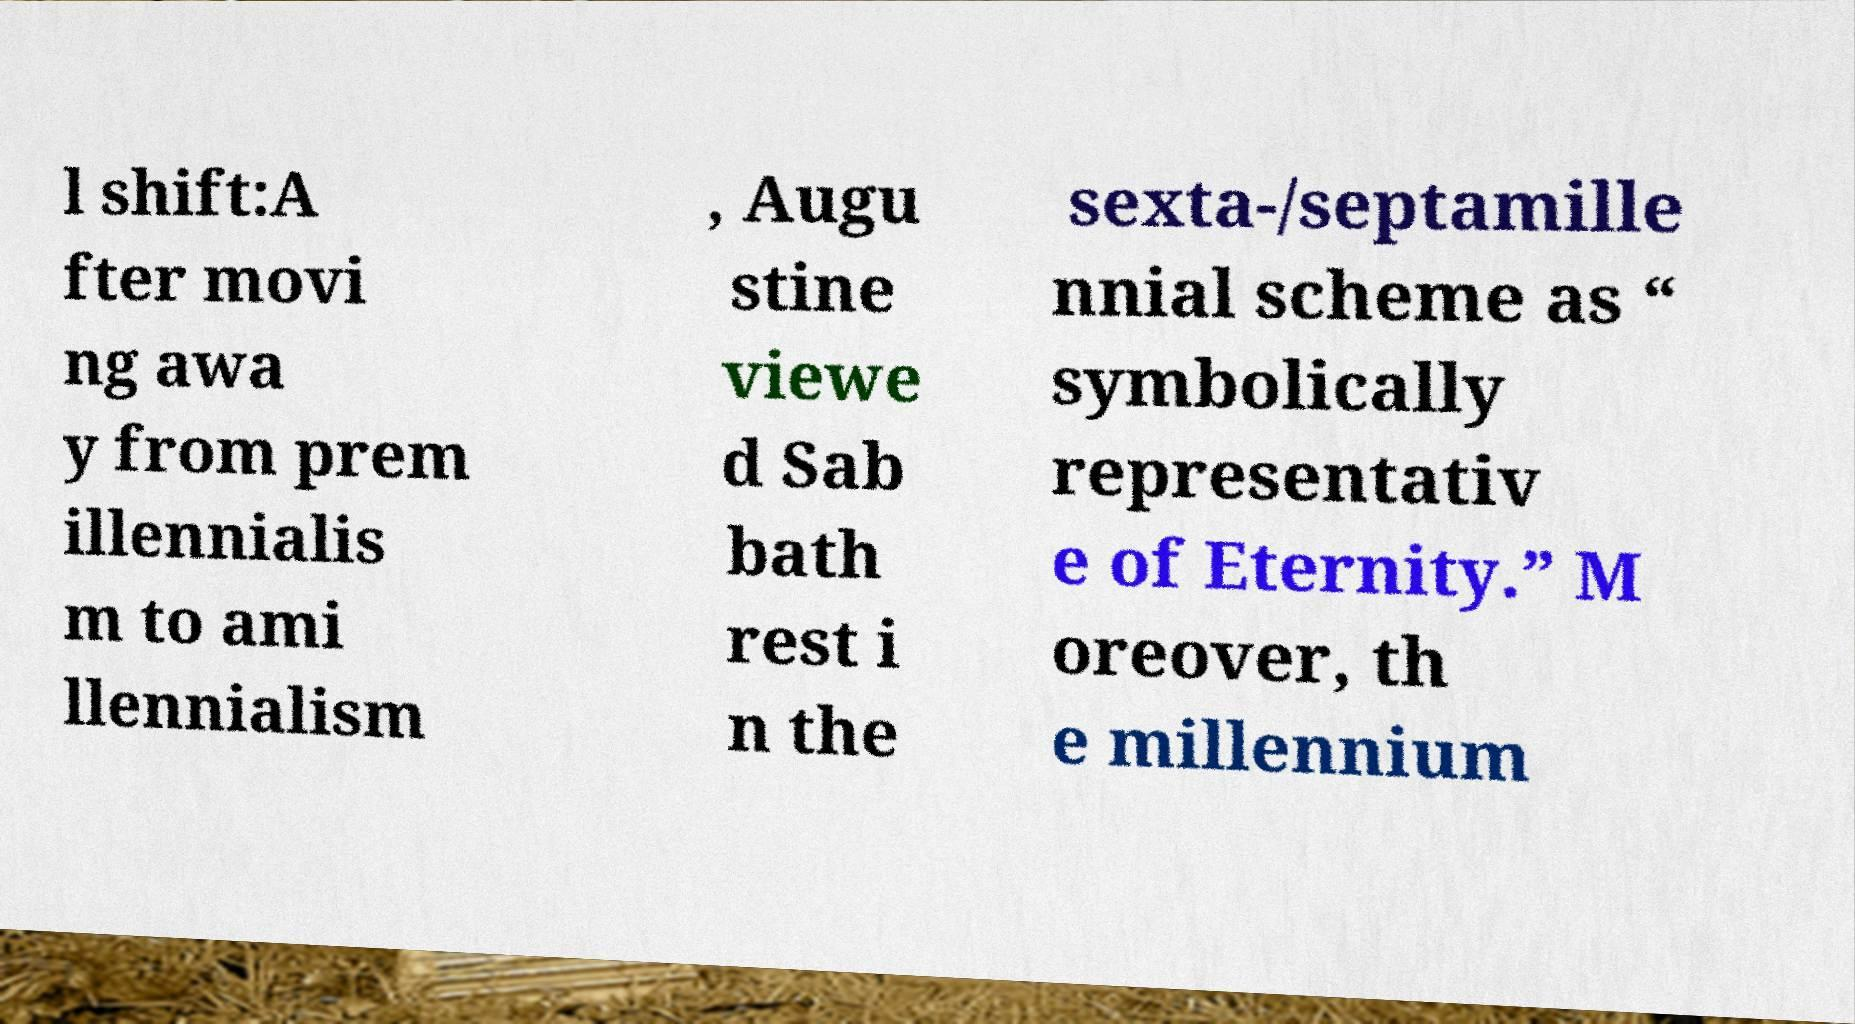What messages or text are displayed in this image? I need them in a readable, typed format. l shift:A fter movi ng awa y from prem illennialis m to ami llennialism , Augu stine viewe d Sab bath rest i n the sexta-/septamille nnial scheme as “ symbolically representativ e of Eternity.” M oreover, th e millennium 